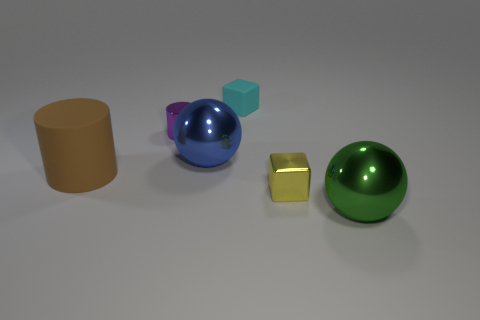Add 3 metallic things. How many objects exist? 9 Subtract all cylinders. How many objects are left? 4 Add 3 blue objects. How many blue objects are left? 4 Add 4 small cyan cubes. How many small cyan cubes exist? 5 Subtract 0 brown cubes. How many objects are left? 6 Subtract all tiny cyan objects. Subtract all big blue shiny balls. How many objects are left? 4 